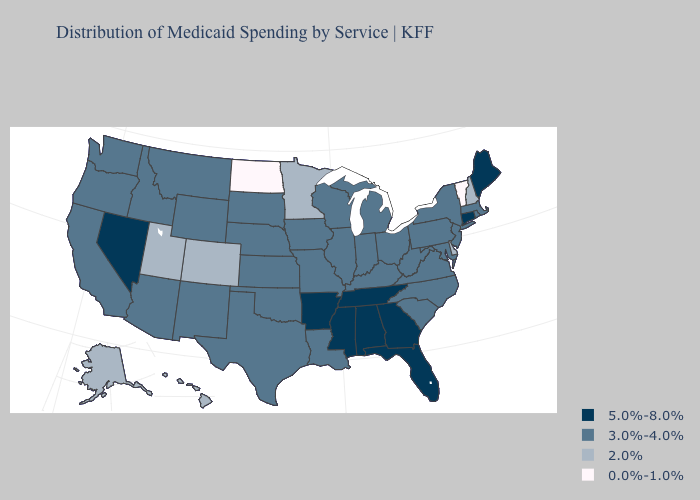Name the states that have a value in the range 0.0%-1.0%?
Be succinct. North Dakota, Vermont. Does Minnesota have the lowest value in the MidWest?
Concise answer only. No. What is the lowest value in states that border New Jersey?
Write a very short answer. 2.0%. Name the states that have a value in the range 0.0%-1.0%?
Be succinct. North Dakota, Vermont. Among the states that border Alabama , which have the highest value?
Keep it brief. Florida, Georgia, Mississippi, Tennessee. Does Georgia have a higher value than Texas?
Quick response, please. Yes. Is the legend a continuous bar?
Answer briefly. No. What is the value of South Dakota?
Keep it brief. 3.0%-4.0%. Does Alaska have the same value as Wyoming?
Concise answer only. No. What is the highest value in states that border North Carolina?
Answer briefly. 5.0%-8.0%. Which states have the lowest value in the USA?
Answer briefly. North Dakota, Vermont. Does Hawaii have a lower value than Oregon?
Concise answer only. Yes. Does Alaska have the same value as Hawaii?
Concise answer only. Yes. What is the value of Oregon?
Write a very short answer. 3.0%-4.0%. 